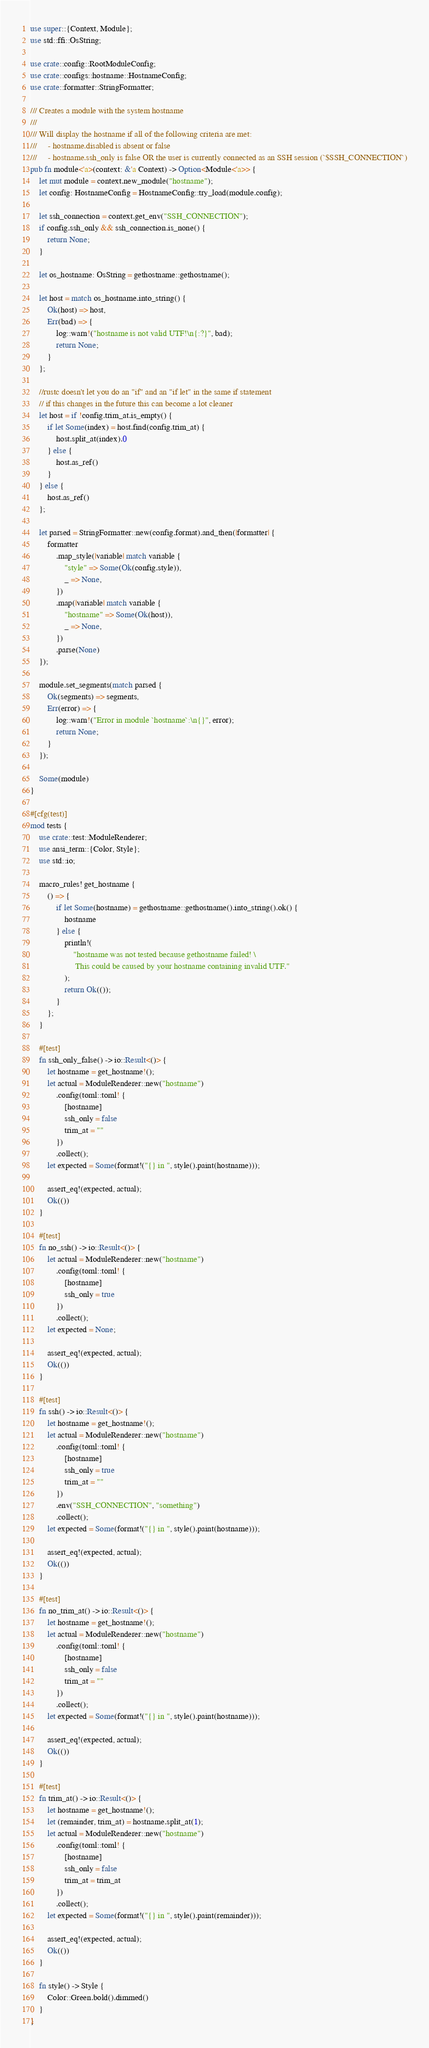<code> <loc_0><loc_0><loc_500><loc_500><_Rust_>use super::{Context, Module};
use std::ffi::OsString;

use crate::config::RootModuleConfig;
use crate::configs::hostname::HostnameConfig;
use crate::formatter::StringFormatter;

/// Creates a module with the system hostname
///
/// Will display the hostname if all of the following criteria are met:
///     - hostname.disabled is absent or false
///     - hostname.ssh_only is false OR the user is currently connected as an SSH session (`$SSH_CONNECTION`)
pub fn module<'a>(context: &'a Context) -> Option<Module<'a>> {
    let mut module = context.new_module("hostname");
    let config: HostnameConfig = HostnameConfig::try_load(module.config);

    let ssh_connection = context.get_env("SSH_CONNECTION");
    if config.ssh_only && ssh_connection.is_none() {
        return None;
    }

    let os_hostname: OsString = gethostname::gethostname();

    let host = match os_hostname.into_string() {
        Ok(host) => host,
        Err(bad) => {
            log::warn!("hostname is not valid UTF!\n{:?}", bad);
            return None;
        }
    };

    //rustc doesn't let you do an "if" and an "if let" in the same if statement
    // if this changes in the future this can become a lot cleaner
    let host = if !config.trim_at.is_empty() {
        if let Some(index) = host.find(config.trim_at) {
            host.split_at(index).0
        } else {
            host.as_ref()
        }
    } else {
        host.as_ref()
    };

    let parsed = StringFormatter::new(config.format).and_then(|formatter| {
        formatter
            .map_style(|variable| match variable {
                "style" => Some(Ok(config.style)),
                _ => None,
            })
            .map(|variable| match variable {
                "hostname" => Some(Ok(host)),
                _ => None,
            })
            .parse(None)
    });

    module.set_segments(match parsed {
        Ok(segments) => segments,
        Err(error) => {
            log::warn!("Error in module `hostname`:\n{}", error);
            return None;
        }
    });

    Some(module)
}

#[cfg(test)]
mod tests {
    use crate::test::ModuleRenderer;
    use ansi_term::{Color, Style};
    use std::io;

    macro_rules! get_hostname {
        () => {
            if let Some(hostname) = gethostname::gethostname().into_string().ok() {
                hostname
            } else {
                println!(
                    "hostname was not tested because gethostname failed! \
                     This could be caused by your hostname containing invalid UTF."
                );
                return Ok(());
            }
        };
    }

    #[test]
    fn ssh_only_false() -> io::Result<()> {
        let hostname = get_hostname!();
        let actual = ModuleRenderer::new("hostname")
            .config(toml::toml! {
                [hostname]
                ssh_only = false
                trim_at = ""
            })
            .collect();
        let expected = Some(format!("{} in ", style().paint(hostname)));

        assert_eq!(expected, actual);
        Ok(())
    }

    #[test]
    fn no_ssh() -> io::Result<()> {
        let actual = ModuleRenderer::new("hostname")
            .config(toml::toml! {
                [hostname]
                ssh_only = true
            })
            .collect();
        let expected = None;

        assert_eq!(expected, actual);
        Ok(())
    }

    #[test]
    fn ssh() -> io::Result<()> {
        let hostname = get_hostname!();
        let actual = ModuleRenderer::new("hostname")
            .config(toml::toml! {
                [hostname]
                ssh_only = true
                trim_at = ""
            })
            .env("SSH_CONNECTION", "something")
            .collect();
        let expected = Some(format!("{} in ", style().paint(hostname)));

        assert_eq!(expected, actual);
        Ok(())
    }

    #[test]
    fn no_trim_at() -> io::Result<()> {
        let hostname = get_hostname!();
        let actual = ModuleRenderer::new("hostname")
            .config(toml::toml! {
                [hostname]
                ssh_only = false
                trim_at = ""
            })
            .collect();
        let expected = Some(format!("{} in ", style().paint(hostname)));

        assert_eq!(expected, actual);
        Ok(())
    }

    #[test]
    fn trim_at() -> io::Result<()> {
        let hostname = get_hostname!();
        let (remainder, trim_at) = hostname.split_at(1);
        let actual = ModuleRenderer::new("hostname")
            .config(toml::toml! {
                [hostname]
                ssh_only = false
                trim_at = trim_at
            })
            .collect();
        let expected = Some(format!("{} in ", style().paint(remainder)));

        assert_eq!(expected, actual);
        Ok(())
    }

    fn style() -> Style {
        Color::Green.bold().dimmed()
    }
}
</code> 